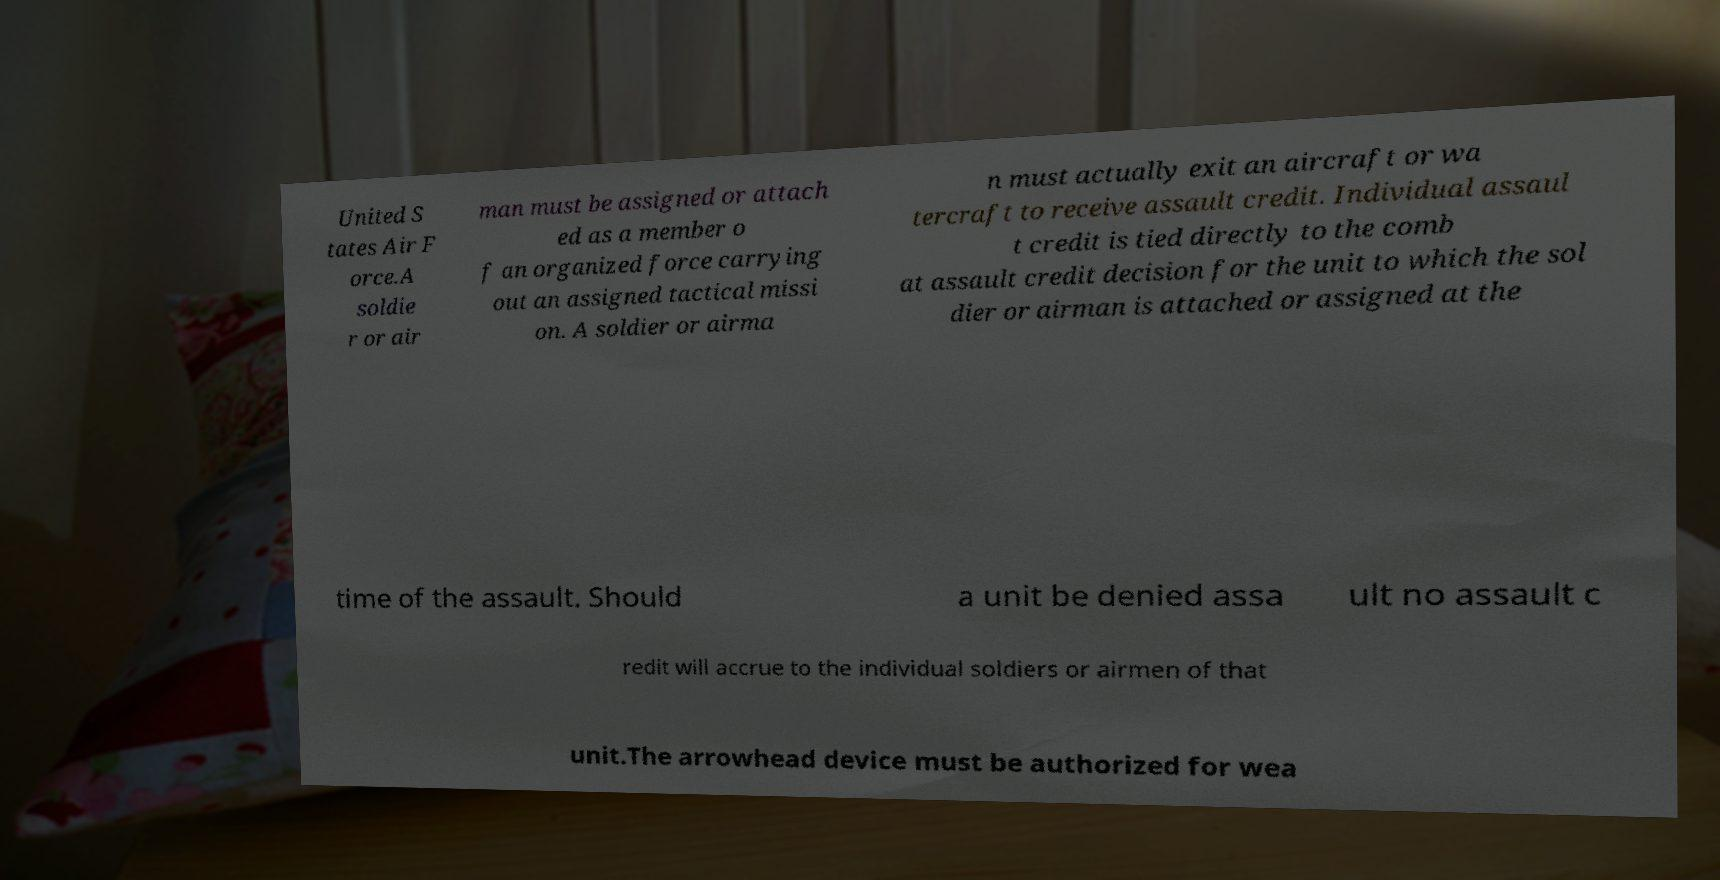Could you extract and type out the text from this image? United S tates Air F orce.A soldie r or air man must be assigned or attach ed as a member o f an organized force carrying out an assigned tactical missi on. A soldier or airma n must actually exit an aircraft or wa tercraft to receive assault credit. Individual assaul t credit is tied directly to the comb at assault credit decision for the unit to which the sol dier or airman is attached or assigned at the time of the assault. Should a unit be denied assa ult no assault c redit will accrue to the individual soldiers or airmen of that unit.The arrowhead device must be authorized for wea 